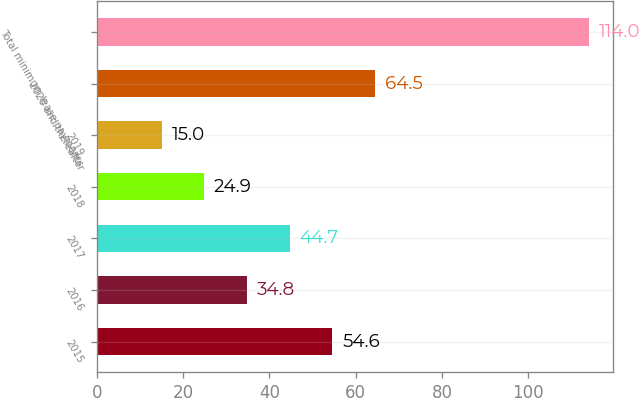Convert chart. <chart><loc_0><loc_0><loc_500><loc_500><bar_chart><fcel>2015<fcel>2016<fcel>2017<fcel>2018<fcel>2019<fcel>2020 and thereafter<fcel>Total minimum lease payments<nl><fcel>54.6<fcel>34.8<fcel>44.7<fcel>24.9<fcel>15<fcel>64.5<fcel>114<nl></chart> 